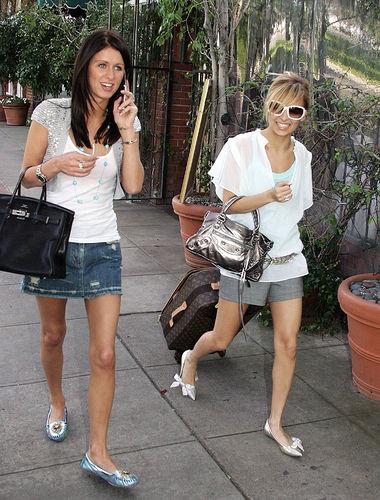Which girl is wearing blue shoes?
Quick response, please. Left. Are they wearing pants?
Write a very short answer. No. Are they male or female?
Be succinct. Female. How many people are walking?
Give a very brief answer. 2. 